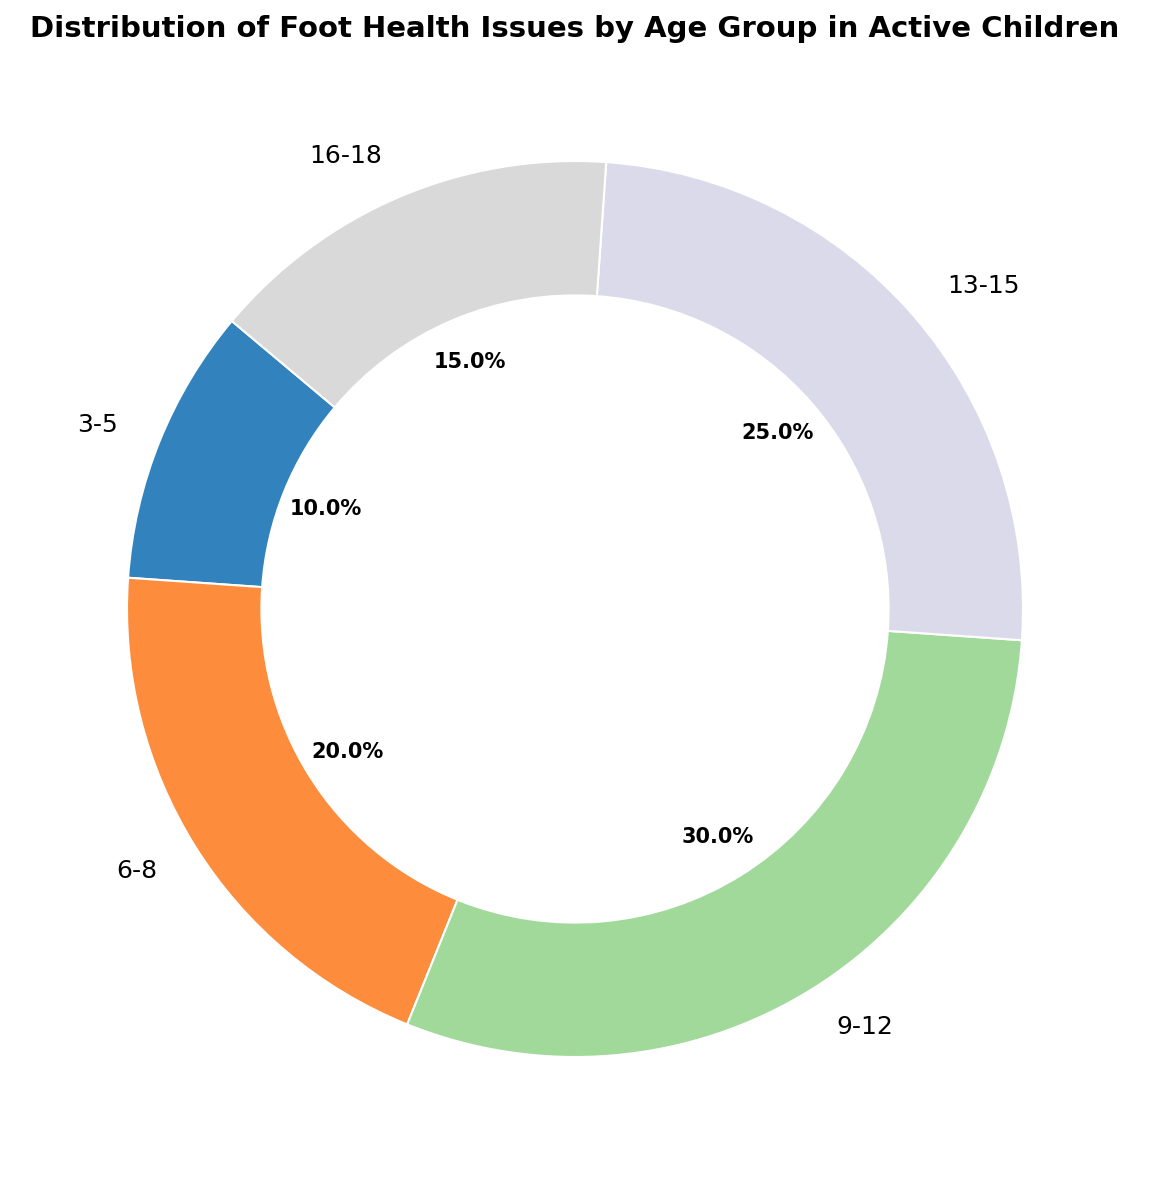Which age group has the highest percentage of foot health issues? Look at the segment of the pie chart with the highest value and refer to its corresponding label. The biggest segment is 9-12 with 30%.
Answer: 9-12 Which age group has the lowest percentage of foot health issues? Look at the segment of the pie chart with the smallest value and refer to its corresponding label. The smallest segment is 3-5 with 10%.
Answer: 3-5 How much greater is the percentage of foot health issues in the 9-12 age group compared to the 3-5 age group? Subtract the percentage of the 3-5 age group from the 9-12 age group percentage (30% - 10%).
Answer: 20% What is the total percentage of foot health issues in children aged 6-12? Sum the percentages of the 6-8 and 9-12 age groups (20% + 30%).
Answer: 50% How does the percentage of foot health issues in the 13-15 age group compare to the 16-18 age group? Compare the values directly: the percentage for 13-15 is 25%, and for 16-18 is 15%, hence 13-15 has a greater percentage.
Answer: Greater What fraction of the total percentage do the 9-12 and the 13-15 age groups combined represent? Add the percentages of the 9-12 and 13-15 age groups (30% + 25%) and relate it to 100%.
Answer: 55% If you combine the percentages of the 3-5 and 6-8 age groups, is it more or less than that of the 13-15 age group? Sum the percentages of the 3-5 and 6-8 age groups (10% + 20% = 30%) and compare it with 25% for the 13-15 group.
Answer: More What is the average percentage of foot health issues across all age groups? Sum all the percentages (10% + 20% + 30% + 25% + 15%) and divide by the number of age groups (5). The calculation is (100% / 5) = 20%.
Answer: 20% Which two age groups collectively have an equal percentage of foot health issues as the 9-12 age group? The 9-12 age group has 30%, so find two segments adding up to 30%, which are the 3-5 and 6-8 groups (10% + 20%).
Answer: 3-5 and 6-8 Which age groups have more than 20% of foot health issues? Look for segments with percentages greater than 20%. Age groups 9-12 (30%) and 13-15 (25%) fit this criterion.
Answer: 9-12 and 13-15 